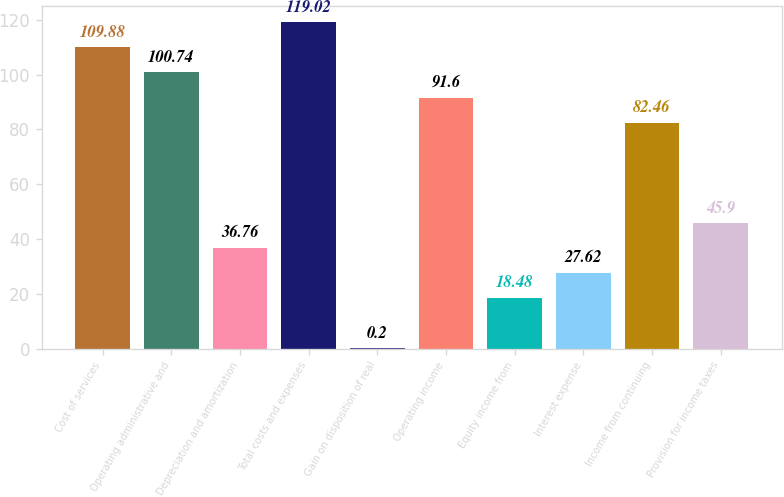Convert chart to OTSL. <chart><loc_0><loc_0><loc_500><loc_500><bar_chart><fcel>Cost of services<fcel>Operating administrative and<fcel>Depreciation and amortization<fcel>Total costs and expenses<fcel>Gain on disposition of real<fcel>Operating income<fcel>Equity income from<fcel>Interest expense<fcel>Income from continuing<fcel>Provision for income taxes<nl><fcel>109.88<fcel>100.74<fcel>36.76<fcel>119.02<fcel>0.2<fcel>91.6<fcel>18.48<fcel>27.62<fcel>82.46<fcel>45.9<nl></chart> 